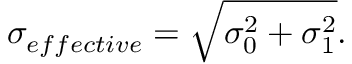<formula> <loc_0><loc_0><loc_500><loc_500>\sigma _ { e f f e c t i v e } = \sqrt { \sigma _ { 0 } ^ { 2 } + \sigma _ { 1 } ^ { 2 } } .</formula> 